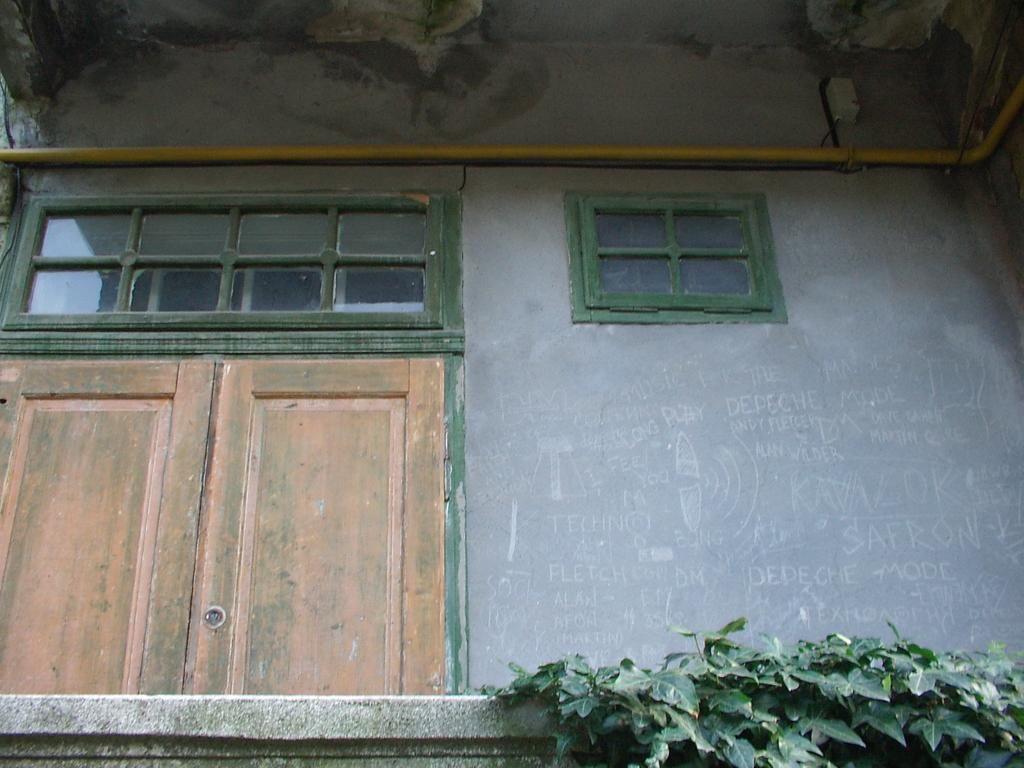What type of living organisms can be seen in the image? Plants are visible in the image. What architectural feature can be seen in the image? There is a wall in the image. What is a common feature of buildings that can be seen in the image? There is a door in the image. What is a feature that allows for ventilation or passage of fluids in the image? There is a pipe in the image. What allows for natural light and ventilation in the image? There is a window in the image. Can you describe the object in the image? There is an object in the image, but its specific details are not mentioned in the facts. What is written on the wall in the image? Something is written on the wall in the image, but its content is not mentioned in the facts. How many clams are visible on the wall in the image? There are no clams visible on the wall in the image. What is the end of the pipe used for in the image? The facts do not mention the purpose or function of the pipe, so it cannot be determined from the image. 